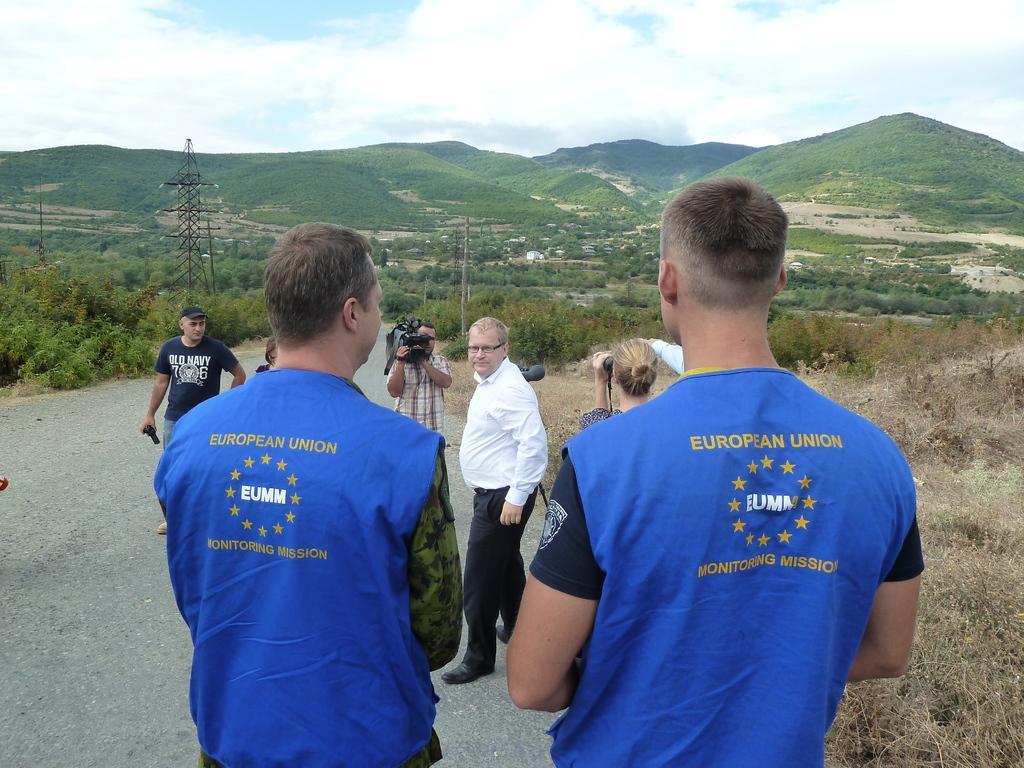Could you give a brief overview of what you see in this image? In the center of the image we can see many persons standing on the road. In the background there is a tower, pole, hills, trees, plants, sky and clouds. 